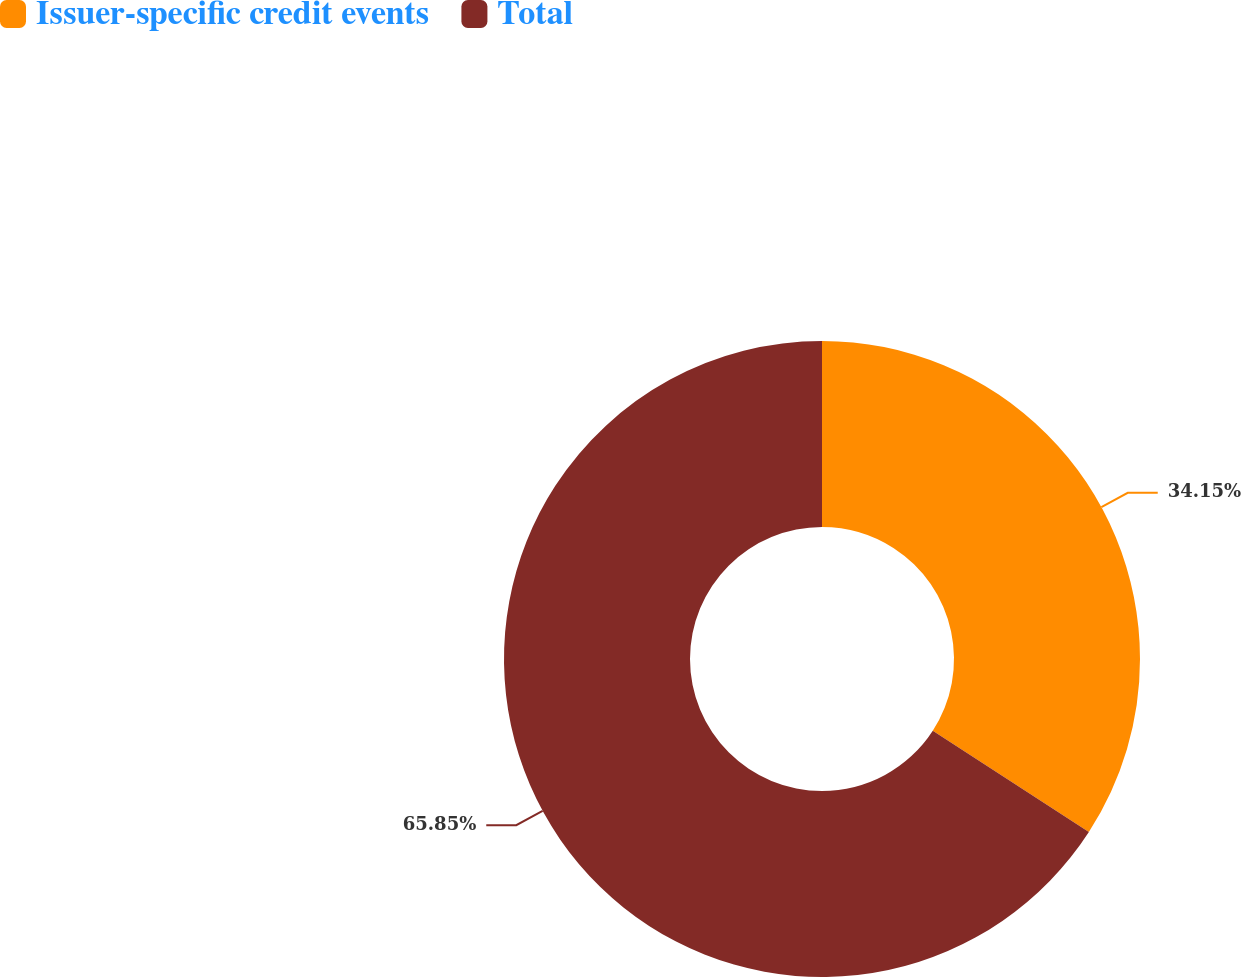<chart> <loc_0><loc_0><loc_500><loc_500><pie_chart><fcel>Issuer-specific credit events<fcel>Total<nl><fcel>34.15%<fcel>65.85%<nl></chart> 